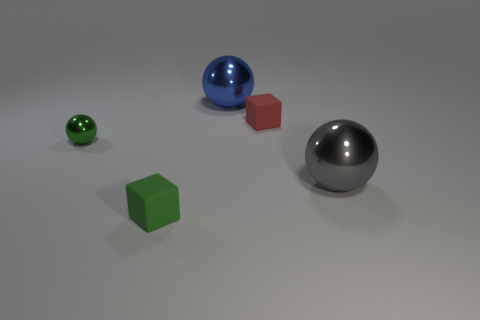Subtract all blue metallic balls. How many balls are left? 2 Add 5 tiny gray cylinders. How many objects exist? 10 Subtract 2 balls. How many balls are left? 1 Subtract all cubes. How many objects are left? 3 Subtract all red blocks. How many blocks are left? 1 Add 5 green rubber things. How many green rubber things exist? 6 Subtract 0 gray cylinders. How many objects are left? 5 Subtract all gray balls. Subtract all brown cubes. How many balls are left? 2 Subtract all big gray shiny things. Subtract all large gray metal cylinders. How many objects are left? 4 Add 3 blue metallic things. How many blue metallic things are left? 4 